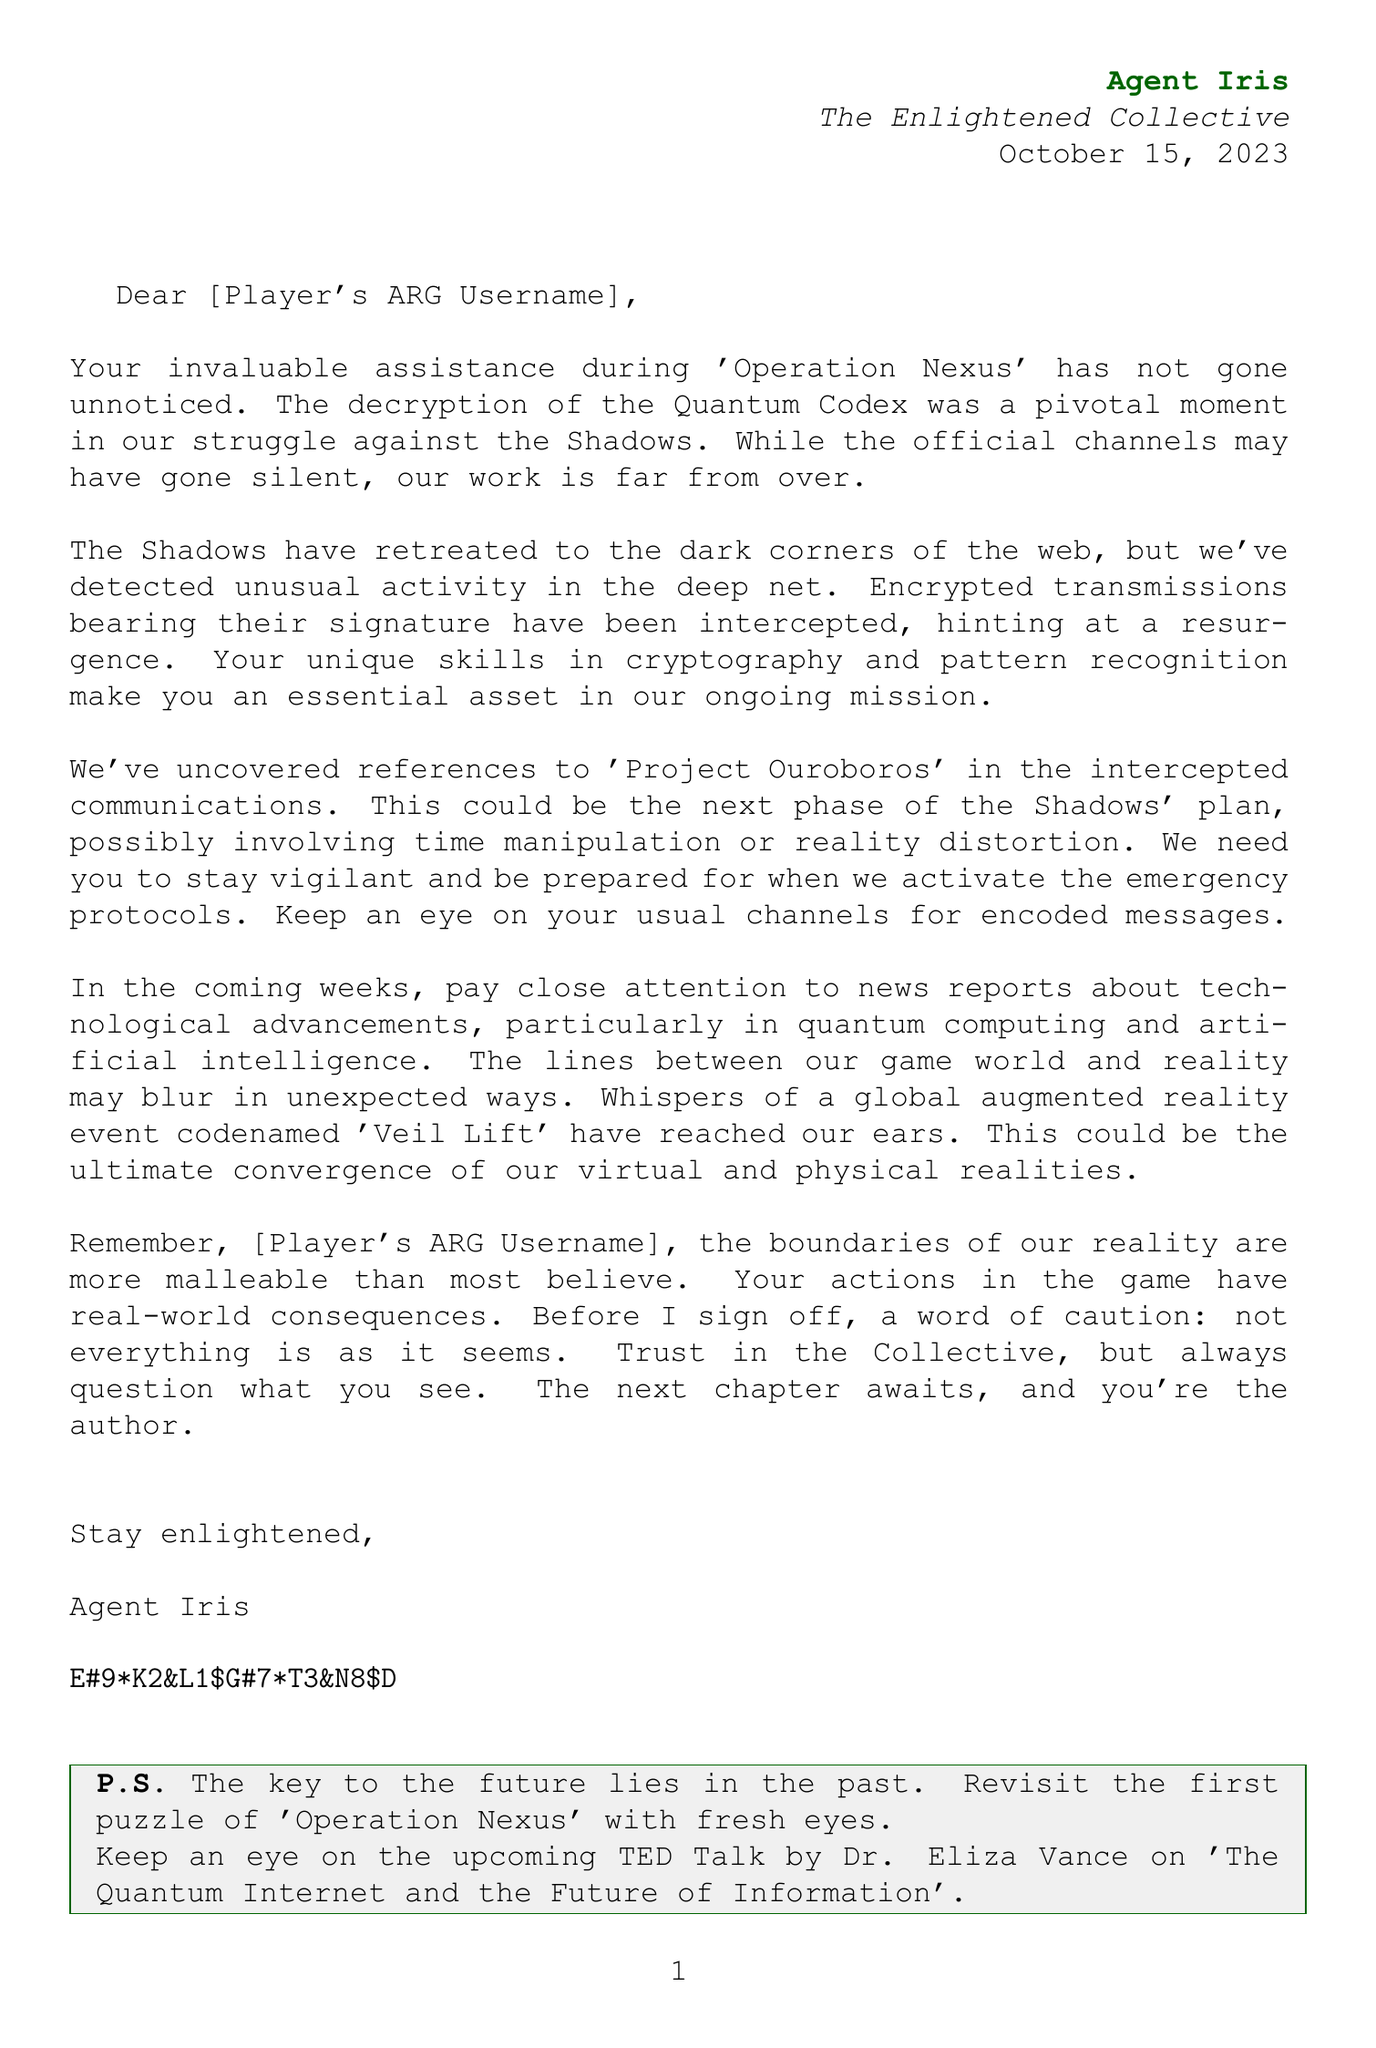What is the character's name? The character's name is stated clearly at the beginning of the letter, attributed to the sender.
Answer: Agent Iris When was the letter dated? The date of the letter is mentioned in the letter header, indicating when it was written.
Answer: October 15, 2023 What operation did the player assist in? The letter references a specific operation where the player's contribution was acknowledged.
Answer: Operation Nexus What is the name of the project mentioned in the letter? A significant project related to the ongoing narrative is highlighted in the document.
Answer: Project Ouroboros What technology should the player pay attention to? There is a specific type of technological advancement that the player is advised to monitor.
Answer: Quantum computing Who is the TED Talk by? The closing section of the letter mentions a speaker for an upcoming talk on a relevant topic.
Answer: Dr. Eliza Vance What does the letter suggest to revisit? The letter includes a note encouraging the player to revisit a certain aspect of the past for potential clues.
Answer: The first puzzle of 'Operation Nexus' What caution is provided at the end of the letter? A word of caution is given to the player regarding the nature of the situation described in the letter.
Answer: Not everything is as it seems What does the letter sign off with? The letter concludes with a specific phrase that connects to the theme of the document.
Answer: Stay enlightened 